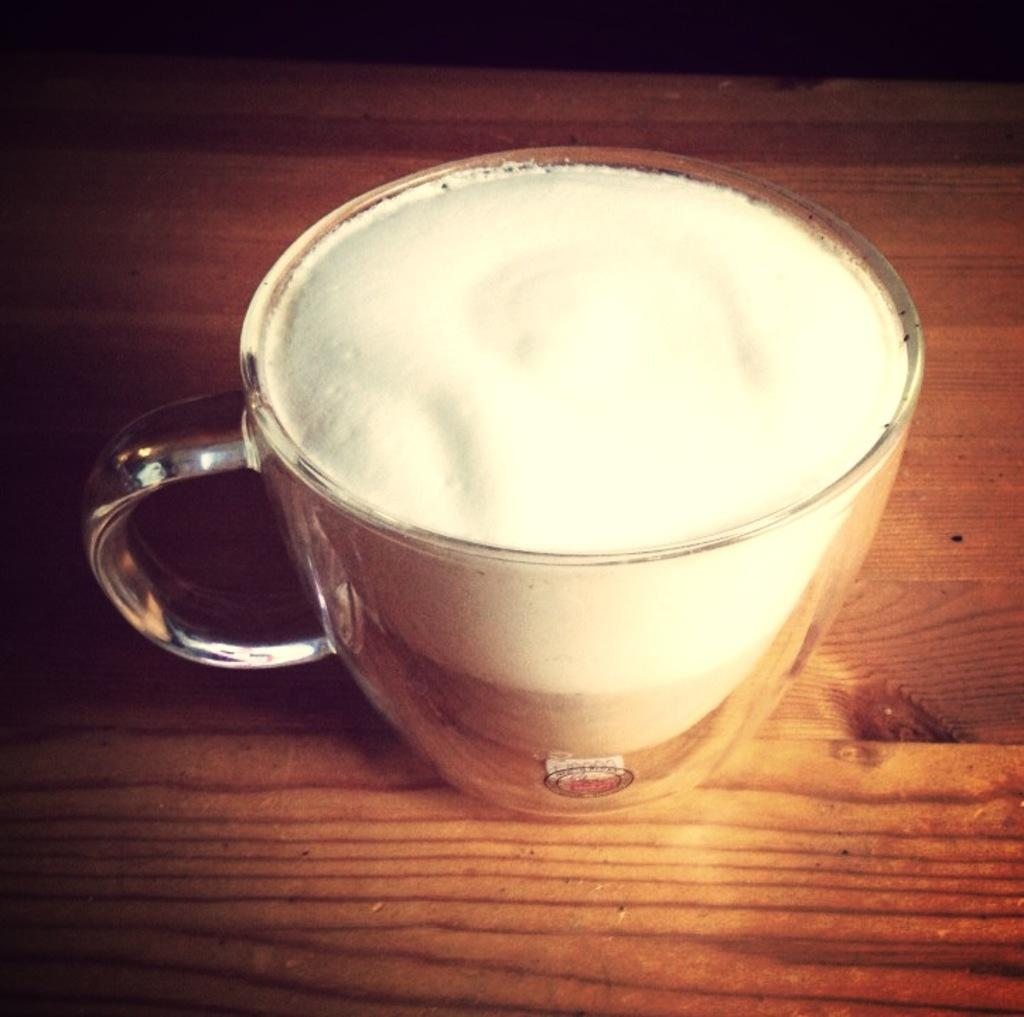What is present in the image that can hold a drink? There is a cup in the image that can hold a drink. What is inside the cup? There is a drink in the cup. How many frogs are sitting on the rim of the cup in the image? There are no frogs present in the image. What type of cherries can be seen floating in the drink? There are no cherries visible in the drink; only a drink is mentioned in the image. 